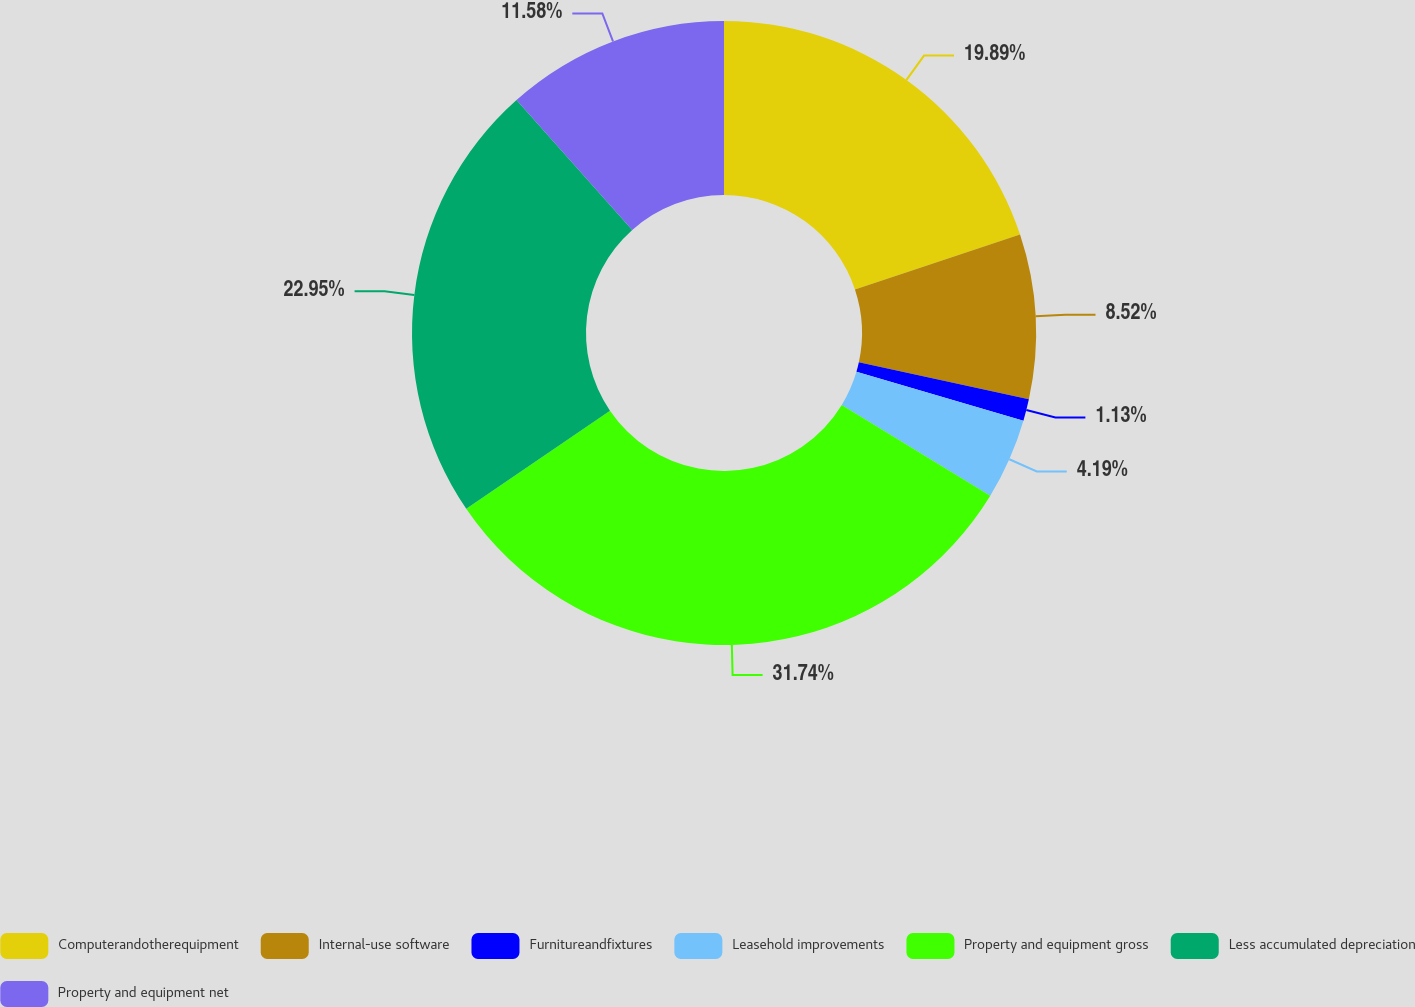<chart> <loc_0><loc_0><loc_500><loc_500><pie_chart><fcel>Computerandotherequipment<fcel>Internal-use software<fcel>Furnitureandfixtures<fcel>Leasehold improvements<fcel>Property and equipment gross<fcel>Less accumulated depreciation<fcel>Property and equipment net<nl><fcel>19.89%<fcel>8.52%<fcel>1.13%<fcel>4.19%<fcel>31.75%<fcel>22.95%<fcel>11.58%<nl></chart> 